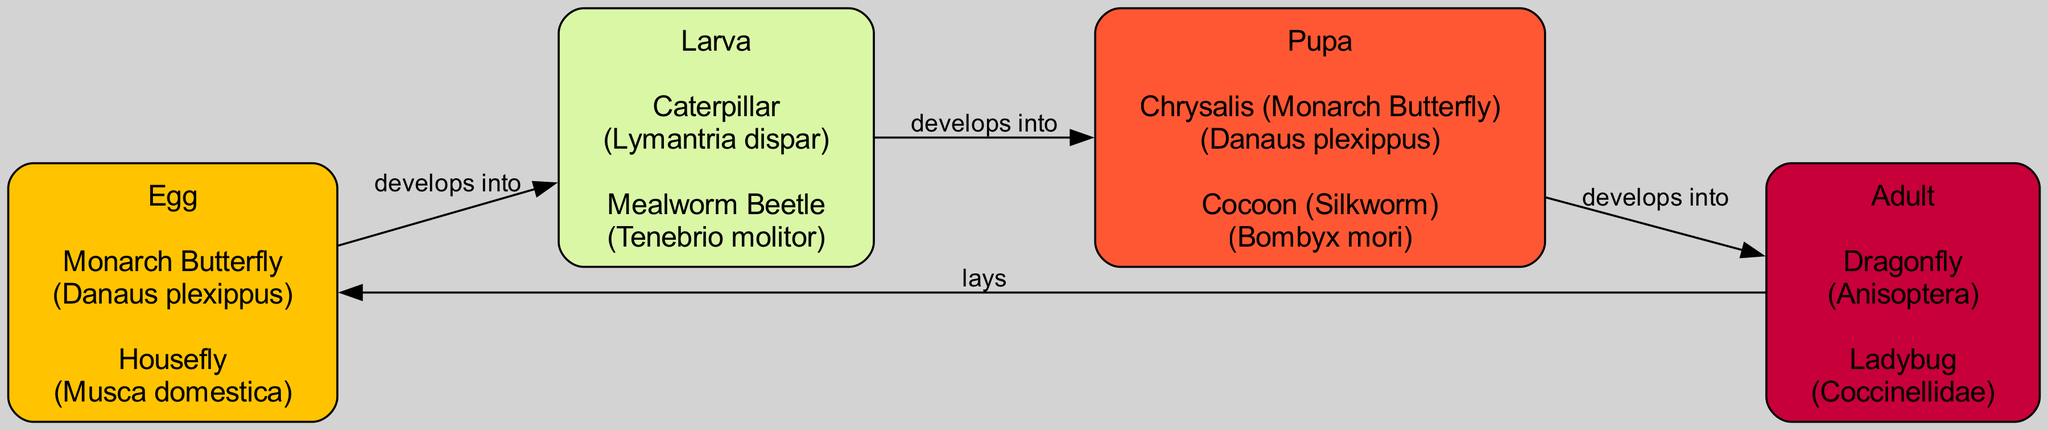What are the four main life cycle stages of insects depicted in the diagram? The diagram outlines the life cycle stages of insects as Egg, Larva, Pupa, and Adult. Each stage is represented clearly, making them easy to identify.
Answer: Egg, Larva, Pupa, Adult How many species are listed under the Larva stage? Under the Larva stage, there are two examples listed: Caterpillar and Mealworm Beetle. This can be counted directly in the diagram where the species are mentioned.
Answer: 2 Which stage directly develops into the Pupa? The diagram shows that the Larva stage develops directly into the Pupa stage. This relationship is indicated by an arrow connecting these two stages.
Answer: Larva What is the scientific name of the Monarch Butterfly in the Egg stage? The Egg stage lists the Monarch Butterfly with its scientific name Danaus plexippus. This information is provided within the node for the Egg stage in the diagram.
Answer: Danaus plexippus Which insect lays eggs in the Adult stage according to the diagram? The diagram indicates that the Adult stage lays eggs, specifically leading to the Egg stage. This reflects the cyclical nature of the life cycle presented in the flow chart.
Answer: Adult Which two examples are provided under the Pupa stage? Under the Pupa stage, the examples provided are Chrysalis (Monarch Butterfly) and Cocoon (Silkworm). Both species are listed in the respective node in the diagram.
Answer: Chrysalis (Monarch Butterfly), Cocoon (Silkworm) What color represents the Egg stage in the diagram? The Egg stage is represented in the diagram using the color yellow (#FFC300). This color coding is established at the beginning of the diagram creation process.
Answer: Yellow How many edges connect the stages in the diagram? The diagram contains four edges, connecting Egg to Larva, Larva to Pupa, Pupa to Adult, and Adult back to Egg, creating a full flow of the life cycle stages.
Answer: 4 